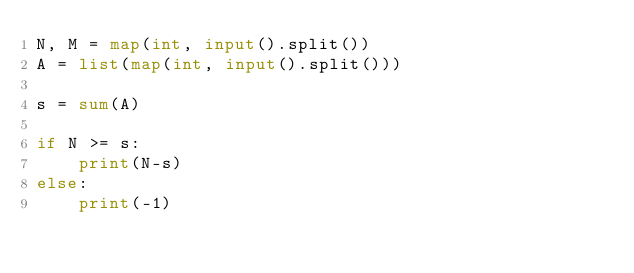Convert code to text. <code><loc_0><loc_0><loc_500><loc_500><_Python_>N, M = map(int, input().split())
A = list(map(int, input().split()))

s = sum(A)

if N >= s:
    print(N-s)
else:
    print(-1)</code> 